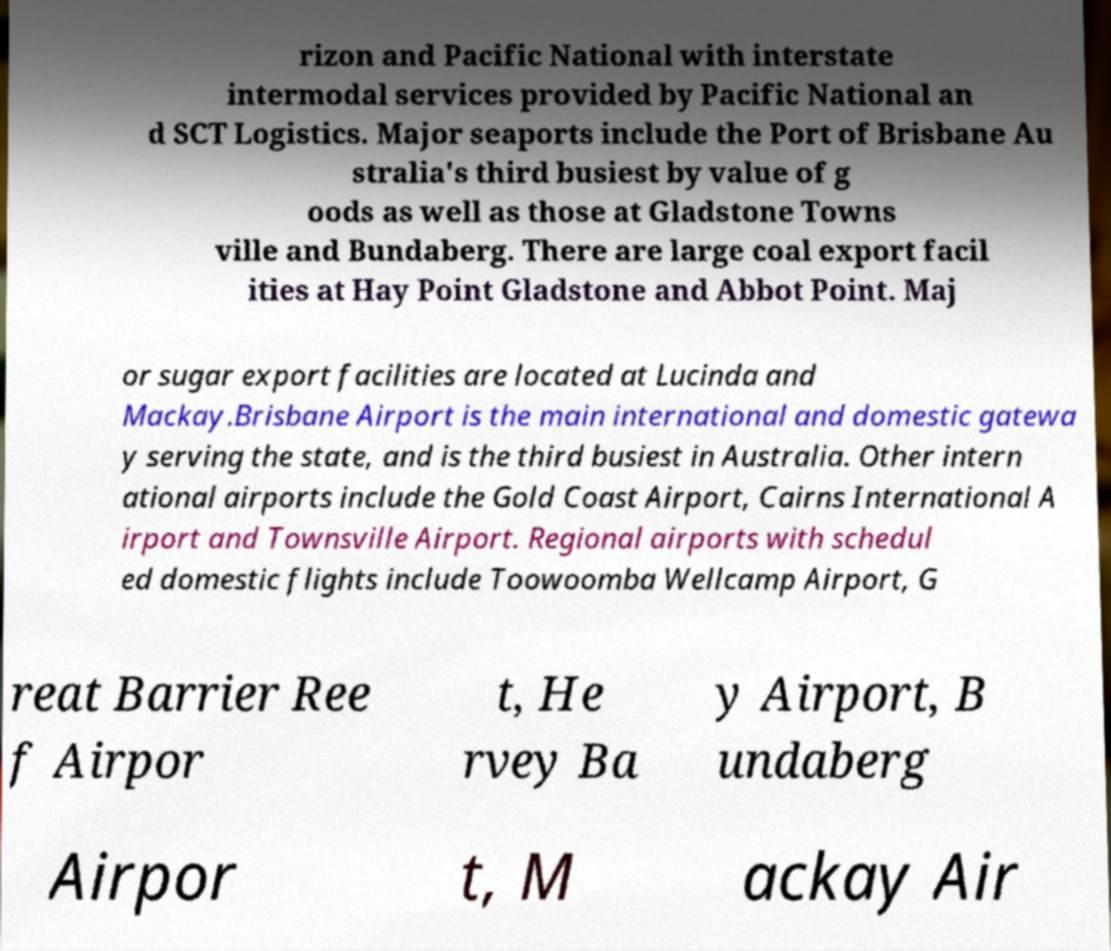Could you extract and type out the text from this image? rizon and Pacific National with interstate intermodal services provided by Pacific National an d SCT Logistics. Major seaports include the Port of Brisbane Au stralia's third busiest by value of g oods as well as those at Gladstone Towns ville and Bundaberg. There are large coal export facil ities at Hay Point Gladstone and Abbot Point. Maj or sugar export facilities are located at Lucinda and Mackay.Brisbane Airport is the main international and domestic gatewa y serving the state, and is the third busiest in Australia. Other intern ational airports include the Gold Coast Airport, Cairns International A irport and Townsville Airport. Regional airports with schedul ed domestic flights include Toowoomba Wellcamp Airport, G reat Barrier Ree f Airpor t, He rvey Ba y Airport, B undaberg Airpor t, M ackay Air 